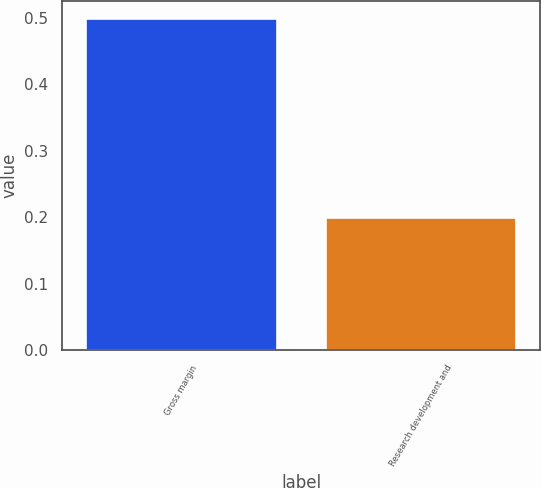<chart> <loc_0><loc_0><loc_500><loc_500><bar_chart><fcel>Gross margin<fcel>Research development and<nl><fcel>0.5<fcel>0.2<nl></chart> 